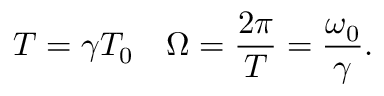Convert formula to latex. <formula><loc_0><loc_0><loc_500><loc_500>T = \gamma T _ { 0 } \quad \Omega = \frac { 2 \pi } { T } = \frac { \omega _ { 0 } } { \gamma } .</formula> 